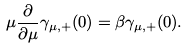<formula> <loc_0><loc_0><loc_500><loc_500>\mu \frac { \partial } { \partial \mu } \gamma _ { \mu , + } ( 0 ) = \beta \gamma _ { \mu , + } ( 0 ) .</formula> 